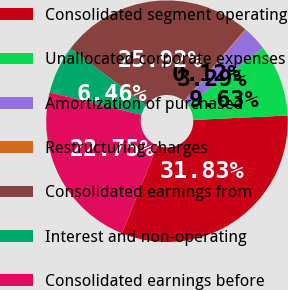<chart> <loc_0><loc_0><loc_500><loc_500><pie_chart><fcel>Consolidated segment operating<fcel>Unallocated corporate expenses<fcel>Amortization of purchased<fcel>Restructuring charges<fcel>Consolidated earnings from<fcel>Interest and non-operating<fcel>Consolidated earnings before<nl><fcel>31.83%<fcel>9.63%<fcel>3.29%<fcel>0.12%<fcel>25.92%<fcel>6.46%<fcel>22.75%<nl></chart> 